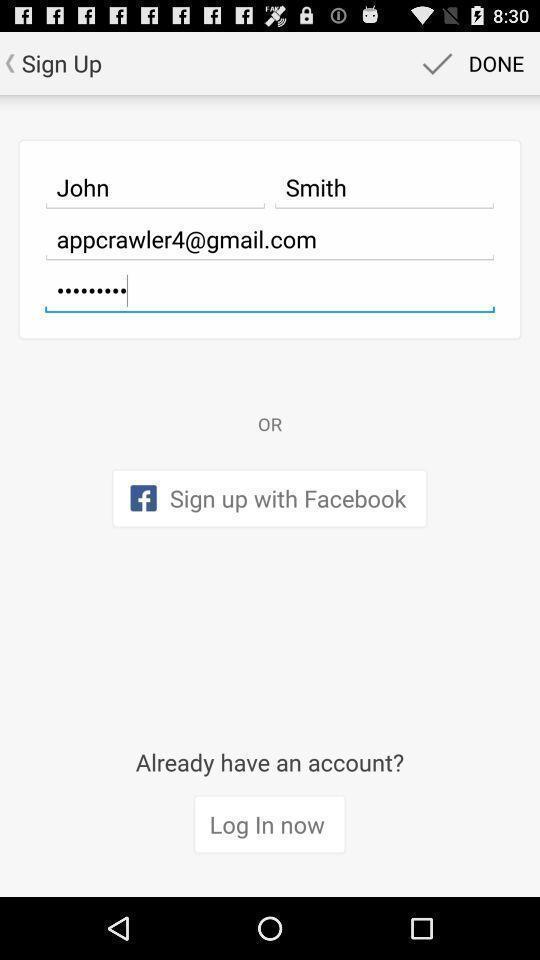What details can you identify in this image? Sign up page. 